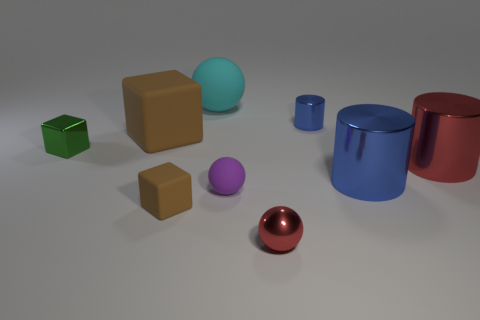Subtract all tiny purple matte balls. How many balls are left? 2 Add 1 blocks. How many objects exist? 10 Subtract all blue cylinders. How many cylinders are left? 1 Subtract all cubes. How many objects are left? 6 Subtract all green cylinders. How many brown blocks are left? 2 Subtract 0 gray cubes. How many objects are left? 9 Subtract 3 blocks. How many blocks are left? 0 Subtract all brown cubes. Subtract all purple balls. How many cubes are left? 1 Subtract all small gray things. Subtract all big blue cylinders. How many objects are left? 8 Add 9 large blue metallic things. How many large blue metallic things are left? 10 